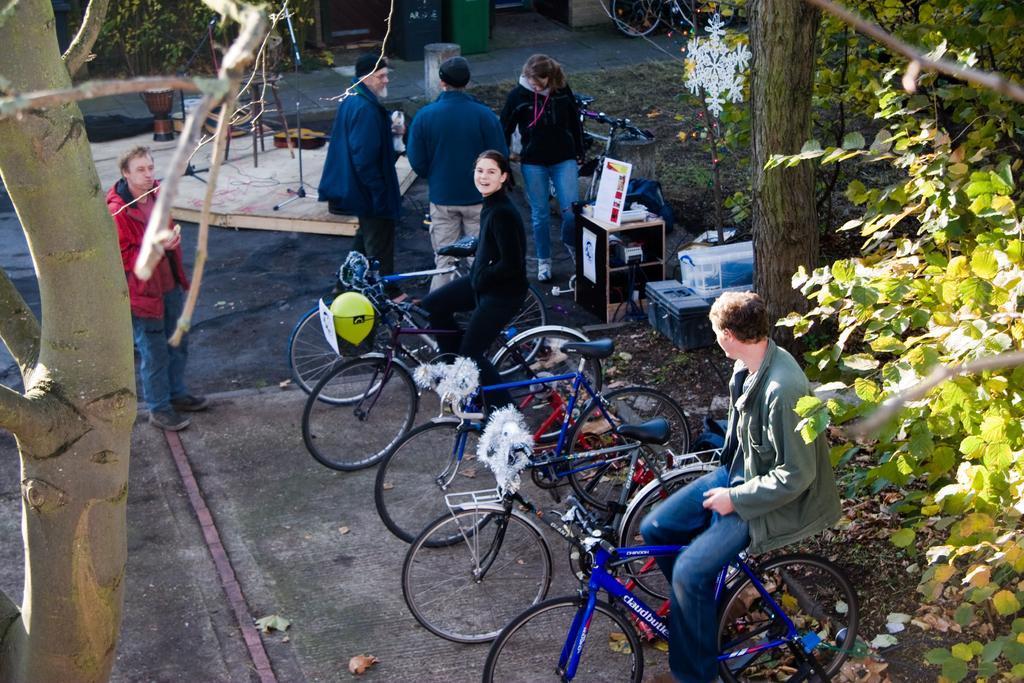Please provide a concise description of this image. In this picture there are a group of people sitting on a bicycle and some other standing in background at tree 